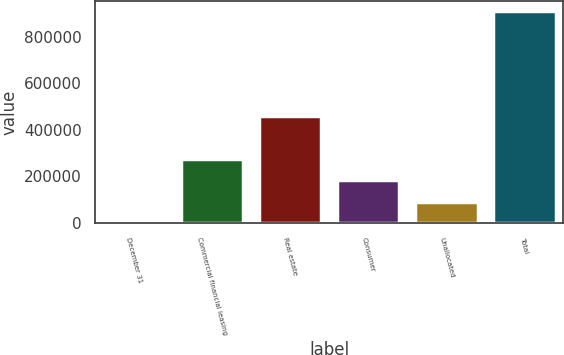<chart> <loc_0><loc_0><loc_500><loc_500><bar_chart><fcel>December 31<fcel>Commercial financial leasing<fcel>Real estate<fcel>Consumer<fcel>Unallocated<fcel>Total<nl><fcel>2011<fcel>273895<fcel>459552<fcel>183267<fcel>92638.9<fcel>908290<nl></chart> 